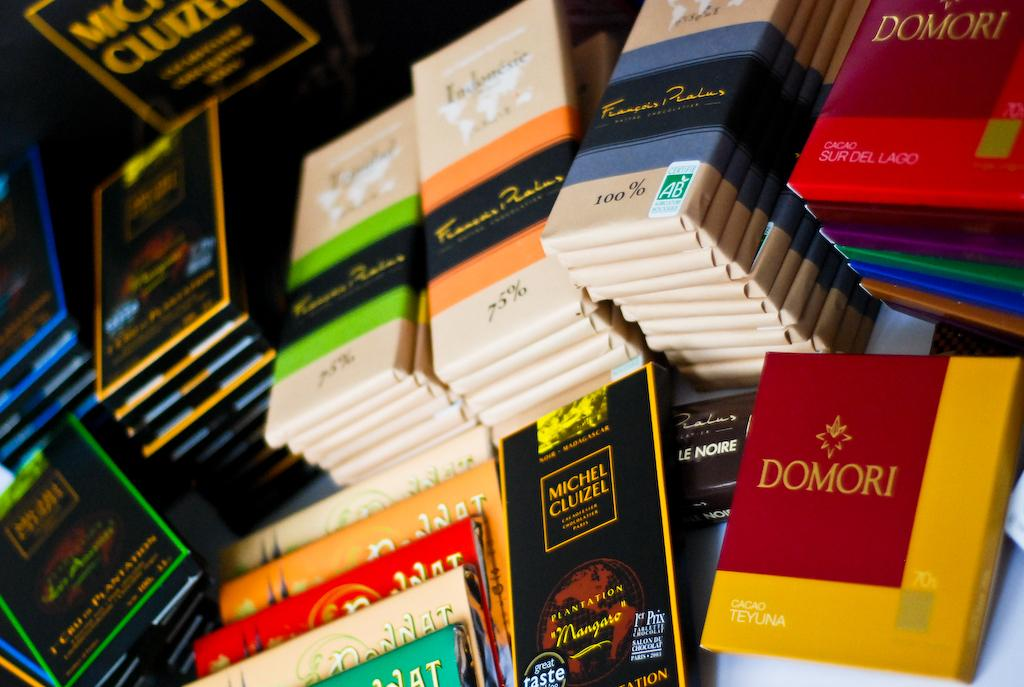<image>
Render a clear and concise summary of the photo. the word domori that is on a book 